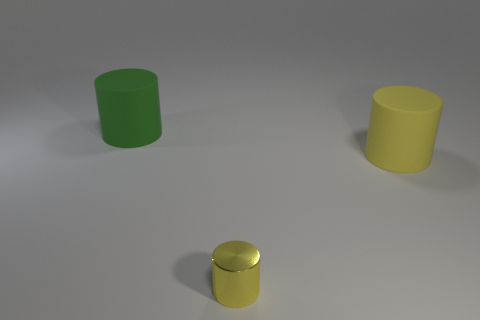Add 3 cylinders. How many objects exist? 6 Add 2 large things. How many large things exist? 4 Subtract 0 cyan spheres. How many objects are left? 3 Subtract all small cylinders. Subtract all tiny yellow cylinders. How many objects are left? 1 Add 3 green objects. How many green objects are left? 4 